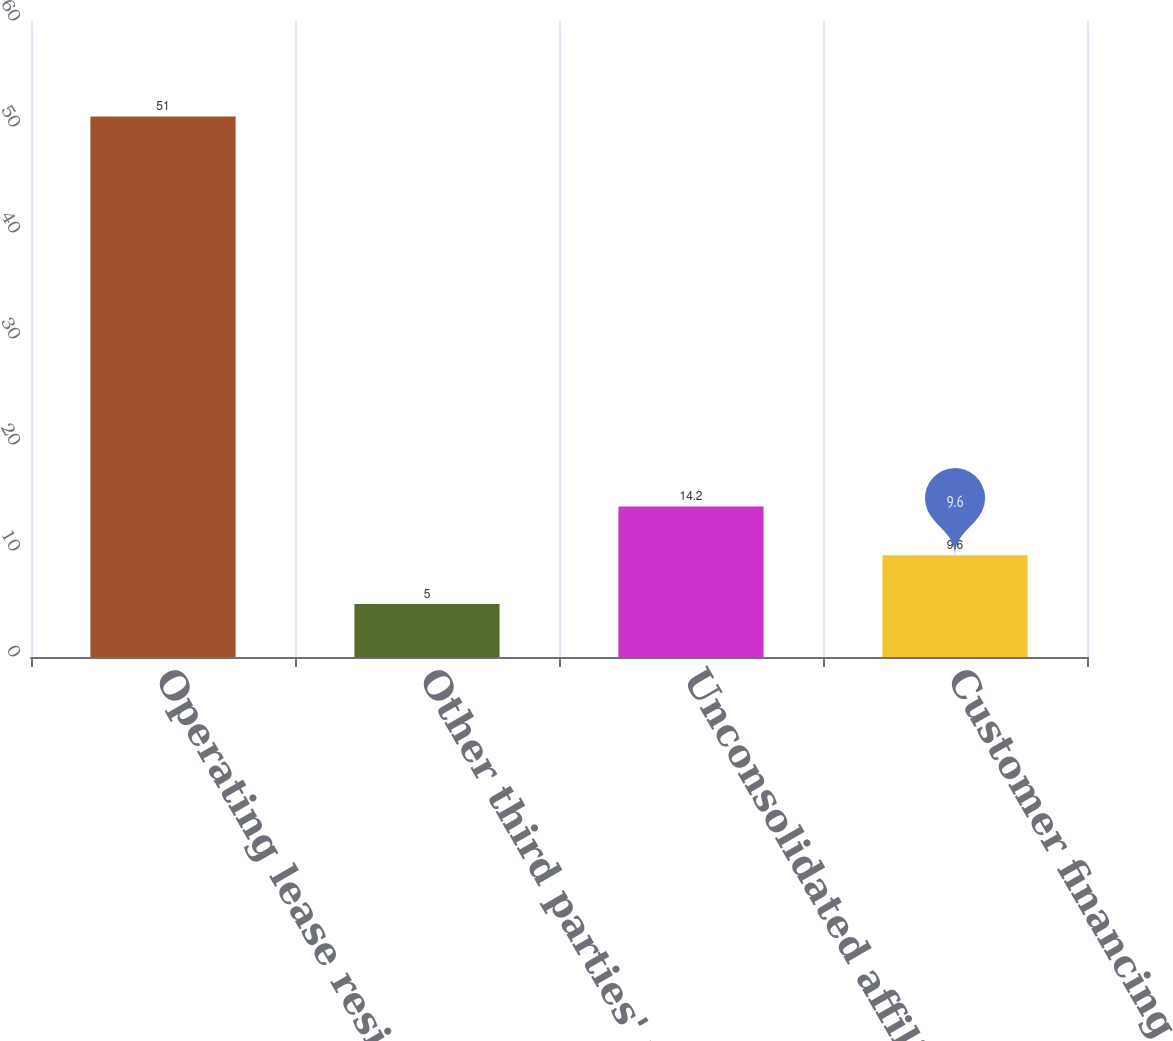Convert chart to OTSL. <chart><loc_0><loc_0><loc_500><loc_500><bar_chart><fcel>Operating lease residual<fcel>Other third parties' financing<fcel>Unconsolidated affiliates'<fcel>Customer financing<nl><fcel>51<fcel>5<fcel>14.2<fcel>9.6<nl></chart> 